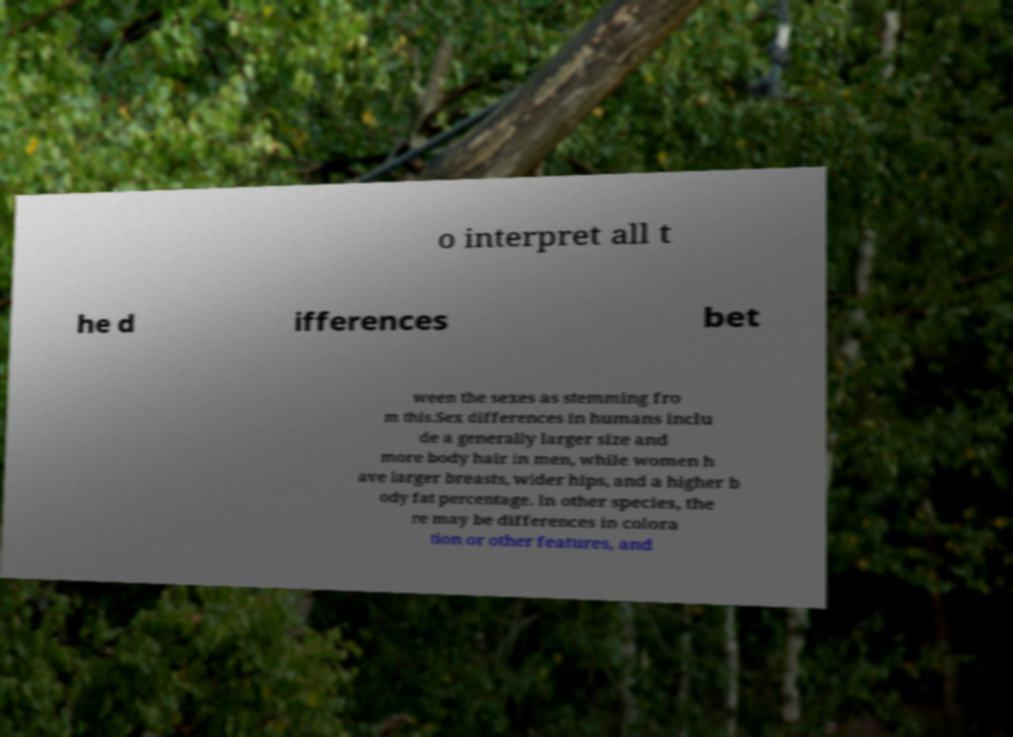There's text embedded in this image that I need extracted. Can you transcribe it verbatim? o interpret all t he d ifferences bet ween the sexes as stemming fro m this.Sex differences in humans inclu de a generally larger size and more body hair in men, while women h ave larger breasts, wider hips, and a higher b ody fat percentage. In other species, the re may be differences in colora tion or other features, and 